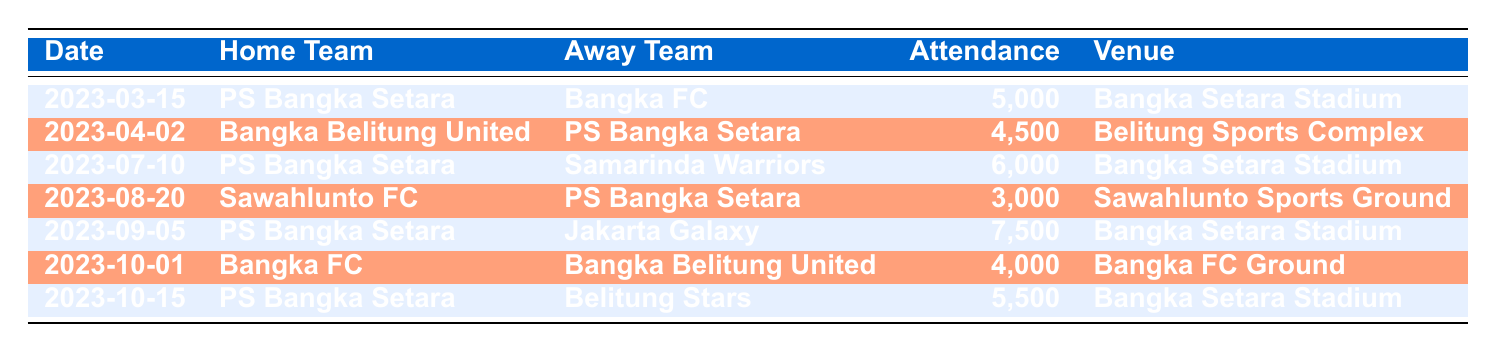What was the highest attendance for PS Bangka Setara matches? The highest attendance for PS Bangka Setara matches is recorded on 2023-09-05 when they played against Jakarta Galaxy with 7500 attendees.
Answer: 7500 What date did PS Bangka Setara play against Bangka FC? PS Bangka Setara played against Bangka FC on 2023-03-15.
Answer: 2023-03-15 Which venue had the most matches listed in the table? Bangka Setara Stadium is mentioned in four rows as the venue for matches involving PS Bangka Setara.
Answer: Bangka Setara Stadium What is the total attendance of all matches involving PS Bangka Setara? The total attendance for matches involving PS Bangka Setara: 5000 (vs Bangka FC) + 4500 (vs Bangka Belitung United) + 6000 (vs Samarinda Warriors) + 3000 (vs Sawahlunto FC) + 7500 (vs Jakarta Galaxy) + 5500 (vs Belitung Stars) = 31500.
Answer: 31500 Did PS Bangka Setara have a match with an attendance of less than 4000? No, all matches involving PS Bangka Setara had attendances above 4000.
Answer: No What was the average attendance of matches held at the Bangka Setara Stadium? The matches held at Bangka Setara Stadium: 5000 (vs Bangka FC), 6000 (vs Samarinda Warriors), 7500 (vs Jakarta Galaxy), and 5500 (vs Belitung Stars). The total attendance is 5000 + 6000 + 7500 + 5500 = 29000, and there are 4 matches, so the average is 29000 / 4 = 7250.
Answer: 7250 How many matches were played by PS Bangka Setara in the given period? PS Bangka Setara played in 6 matches as listed in the table.
Answer: 6 What was the attendance for the match between Bangka FC and Bangka Belitung United? The attendance for the match on 2023-10-01 between Bangka FC and Bangka Belitung United was 4000.
Answer: 4000 